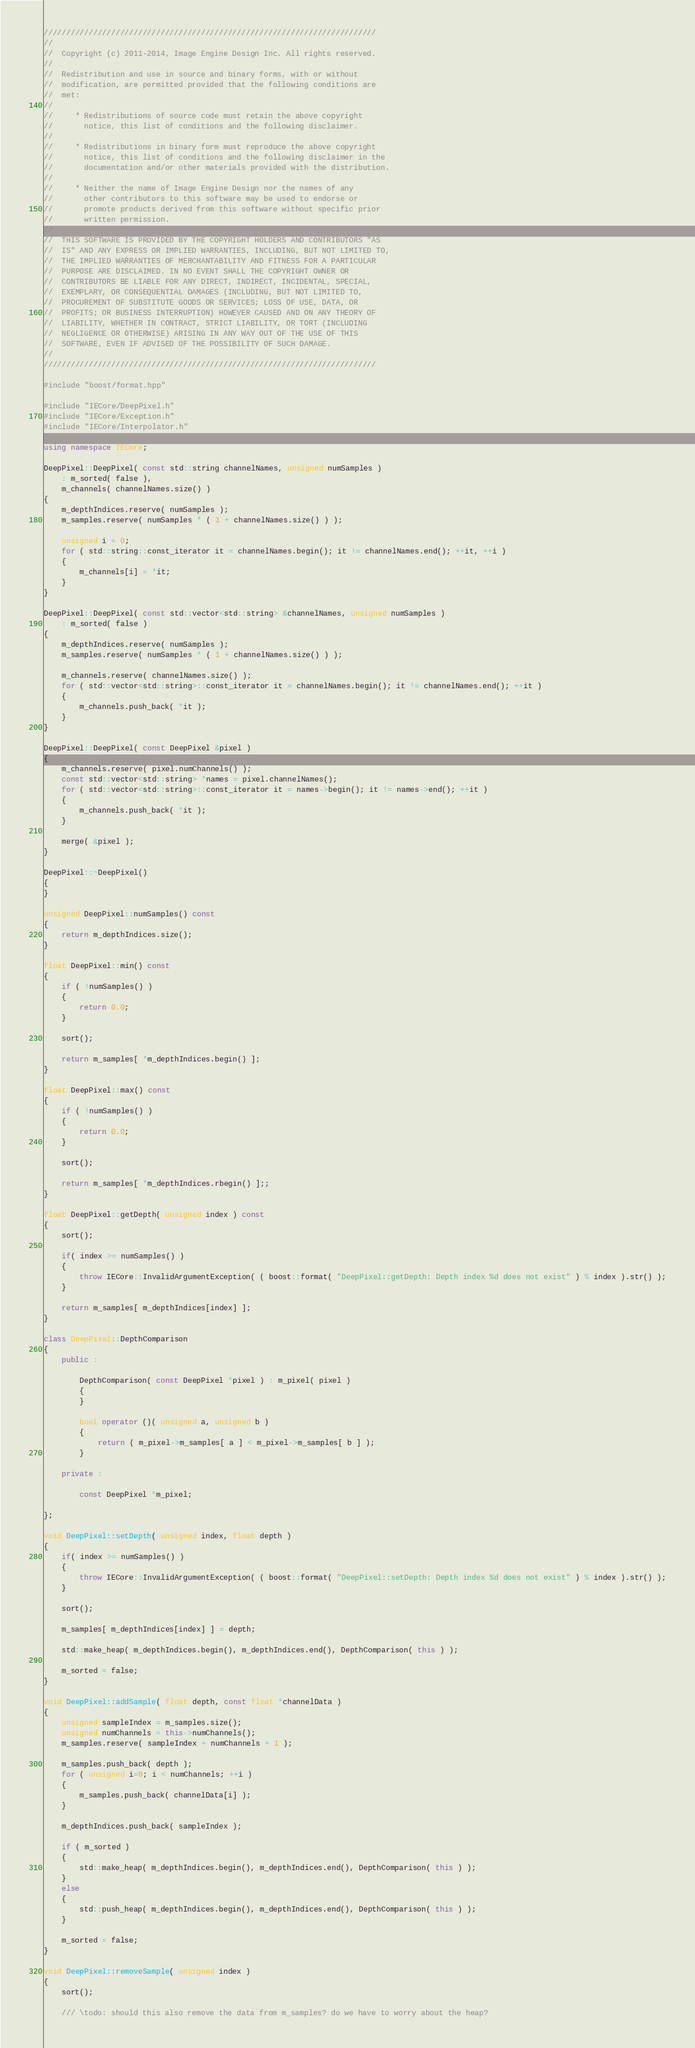<code> <loc_0><loc_0><loc_500><loc_500><_C++_>//////////////////////////////////////////////////////////////////////////
//
//  Copyright (c) 2011-2014, Image Engine Design Inc. All rights reserved.
//
//  Redistribution and use in source and binary forms, with or without
//  modification, are permitted provided that the following conditions are
//  met:
//
//     * Redistributions of source code must retain the above copyright
//       notice, this list of conditions and the following disclaimer.
//
//     * Redistributions in binary form must reproduce the above copyright
//       notice, this list of conditions and the following disclaimer in the
//       documentation and/or other materials provided with the distribution.
//
//     * Neither the name of Image Engine Design nor the names of any
//       other contributors to this software may be used to endorse or
//       promote products derived from this software without specific prior
//       written permission.
//
//  THIS SOFTWARE IS PROVIDED BY THE COPYRIGHT HOLDERS AND CONTRIBUTORS "AS
//  IS" AND ANY EXPRESS OR IMPLIED WARRANTIES, INCLUDING, BUT NOT LIMITED TO,
//  THE IMPLIED WARRANTIES OF MERCHANTABILITY AND FITNESS FOR A PARTICULAR
//  PURPOSE ARE DISCLAIMED. IN NO EVENT SHALL THE COPYRIGHT OWNER OR
//  CONTRIBUTORS BE LIABLE FOR ANY DIRECT, INDIRECT, INCIDENTAL, SPECIAL,
//  EXEMPLARY, OR CONSEQUENTIAL DAMAGES (INCLUDING, BUT NOT LIMITED TO,
//  PROCUREMENT OF SUBSTITUTE GOODS OR SERVICES; LOSS OF USE, DATA, OR
//  PROFITS; OR BUSINESS INTERRUPTION) HOWEVER CAUSED AND ON ANY THEORY OF
//  LIABILITY, WHETHER IN CONTRACT, STRICT LIABILITY, OR TORT (INCLUDING
//  NEGLIGENCE OR OTHERWISE) ARISING IN ANY WAY OUT OF THE USE OF THIS
//  SOFTWARE, EVEN IF ADVISED OF THE POSSIBILITY OF SUCH DAMAGE.
//
//////////////////////////////////////////////////////////////////////////

#include "boost/format.hpp"

#include "IECore/DeepPixel.h"
#include "IECore/Exception.h"
#include "IECore/Interpolator.h"

using namespace IECore;

DeepPixel::DeepPixel( const std::string channelNames, unsigned numSamples )
	: m_sorted( false ),
	m_channels( channelNames.size() )
{
	m_depthIndices.reserve( numSamples );
	m_samples.reserve( numSamples * ( 1 + channelNames.size() ) );
	
	unsigned i = 0;
	for ( std::string::const_iterator it = channelNames.begin(); it != channelNames.end(); ++it, ++i )
	{
		m_channels[i] = *it;
	}
}

DeepPixel::DeepPixel( const std::vector<std::string> &channelNames, unsigned numSamples )
	: m_sorted( false ) 
{
	m_depthIndices.reserve( numSamples );
	m_samples.reserve( numSamples * ( 1 + channelNames.size() ) );
	
	m_channels.reserve( channelNames.size() );
	for ( std::vector<std::string>::const_iterator it = channelNames.begin(); it != channelNames.end(); ++it )
	{
		m_channels.push_back( *it );
	}
}

DeepPixel::DeepPixel( const DeepPixel &pixel )
{
	m_channels.reserve( pixel.numChannels() );
	const std::vector<std::string> *names = pixel.channelNames();
	for ( std::vector<std::string>::const_iterator it = names->begin(); it != names->end(); ++it )
	{
		m_channels.push_back( *it );
	}
	
	merge( &pixel );
}

DeepPixel::~DeepPixel()
{
}

unsigned DeepPixel::numSamples() const
{
	return m_depthIndices.size();
}

float DeepPixel::min() const
{
	if ( !numSamples() )
	{
		return 0.0;
	}
	
	sort();
	
	return m_samples[ *m_depthIndices.begin() ];
}

float DeepPixel::max() const
{
	if ( !numSamples() )
	{
		return 0.0;
	}
	
	sort();
	
	return m_samples[ *m_depthIndices.rbegin() ];;
}

float DeepPixel::getDepth( unsigned index ) const
{
	sort();
	
	if( index >= numSamples() )
	{
		throw IECore::InvalidArgumentException( ( boost::format( "DeepPixel::getDepth: Depth index %d does not exist" ) % index ).str() );
	}
	
	return m_samples[ m_depthIndices[index] ];
}

class DeepPixel::DepthComparison
{	
	public :
		
		DepthComparison( const DeepPixel *pixel ) : m_pixel( pixel )
		{
		}
		
		bool operator ()( unsigned a, unsigned b )
		{
			return ( m_pixel->m_samples[ a ] < m_pixel->m_samples[ b ] );
		}
	
	private :
		
		const DeepPixel *m_pixel;

};

void DeepPixel::setDepth( unsigned index, float depth )
{
	if( index >= numSamples() )
	{
		throw IECore::InvalidArgumentException( ( boost::format( "DeepPixel::setDepth: Depth index %d does not exist" ) % index ).str() );
	}
	
	sort();
	
	m_samples[ m_depthIndices[index] ] = depth;
	
	std::make_heap( m_depthIndices.begin(), m_depthIndices.end(), DepthComparison( this ) );
	
	m_sorted = false;
}

void DeepPixel::addSample( float depth, const float *channelData )
{
	unsigned sampleIndex = m_samples.size();
	unsigned numChannels = this->numChannels();
	m_samples.reserve( sampleIndex + numChannels + 1 );
	
	m_samples.push_back( depth );
	for ( unsigned i=0; i < numChannels; ++i )
	{
		m_samples.push_back( channelData[i] );
	}
	
	m_depthIndices.push_back( sampleIndex );
	
	if ( m_sorted )
	{
		std::make_heap( m_depthIndices.begin(), m_depthIndices.end(), DepthComparison( this ) );
	}
	else
	{
		std::push_heap( m_depthIndices.begin(), m_depthIndices.end(), DepthComparison( this ) );
	}
	
	m_sorted = false;
}

void DeepPixel::removeSample( unsigned index )
{
	sort();
	
	/// \todo: should this also remove the data from m_samples? do we have to worry about the heap?</code> 